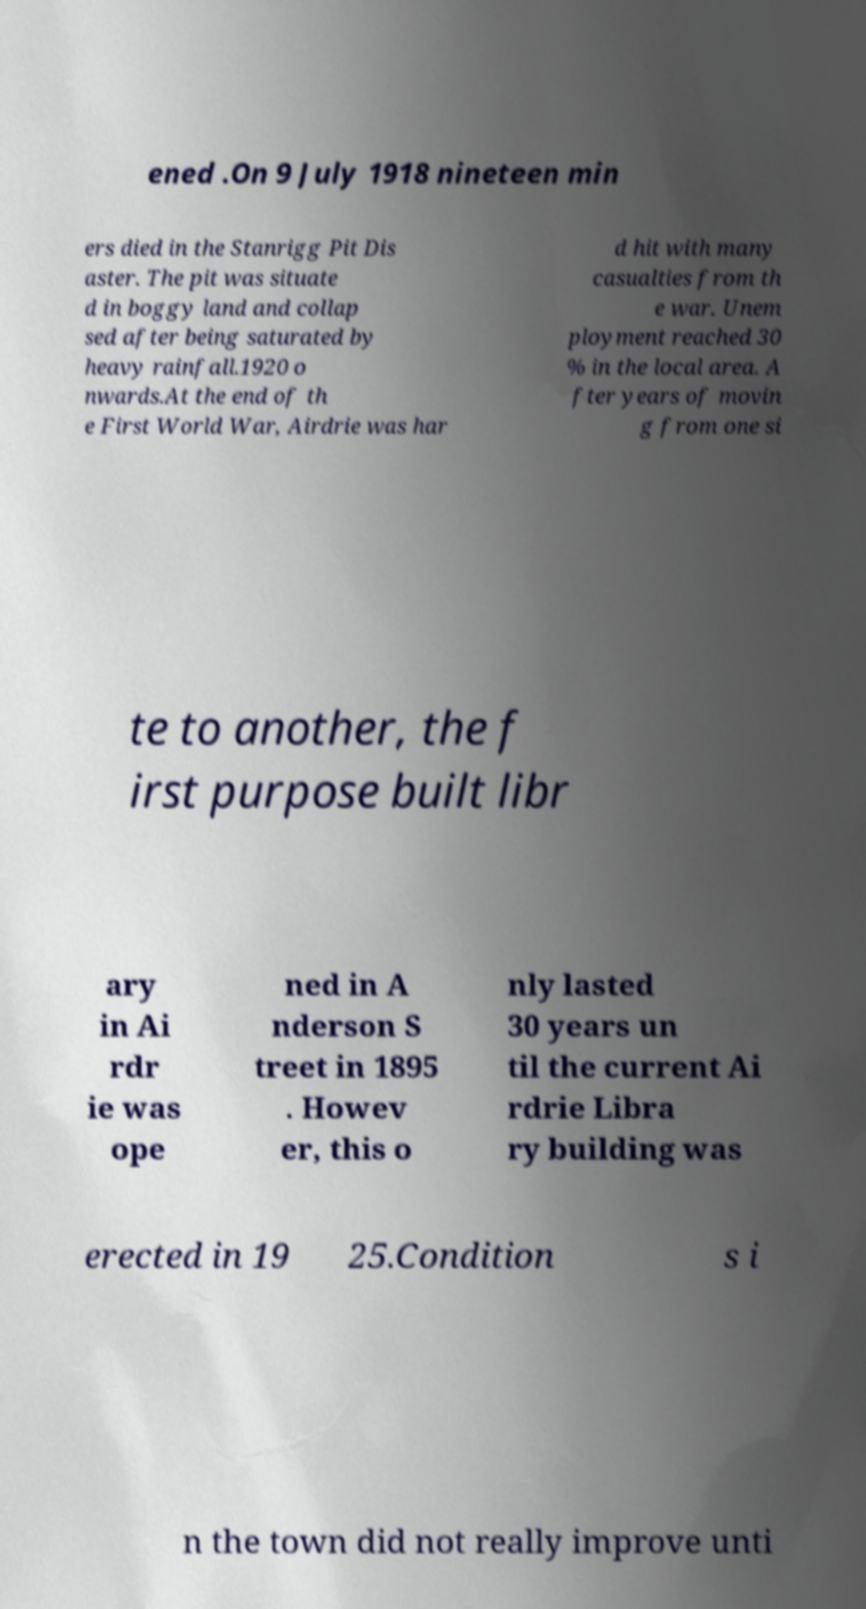There's text embedded in this image that I need extracted. Can you transcribe it verbatim? ened .On 9 July 1918 nineteen min ers died in the Stanrigg Pit Dis aster. The pit was situate d in boggy land and collap sed after being saturated by heavy rainfall.1920 o nwards.At the end of th e First World War, Airdrie was har d hit with many casualties from th e war. Unem ployment reached 30 % in the local area. A fter years of movin g from one si te to another, the f irst purpose built libr ary in Ai rdr ie was ope ned in A nderson S treet in 1895 . Howev er, this o nly lasted 30 years un til the current Ai rdrie Libra ry building was erected in 19 25.Condition s i n the town did not really improve unti 